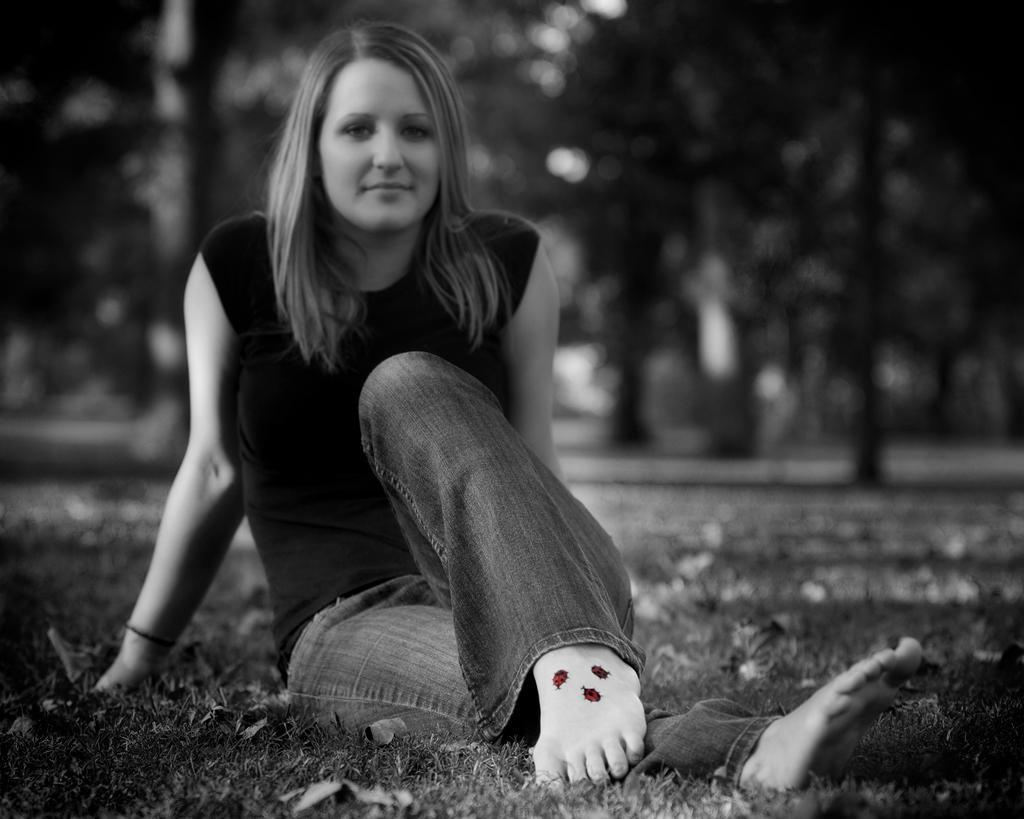Please provide a concise description of this image. In this picture there is a woman sitting on a greenery ground and there are few insect tattoos on her leg and there are trees in the background. 